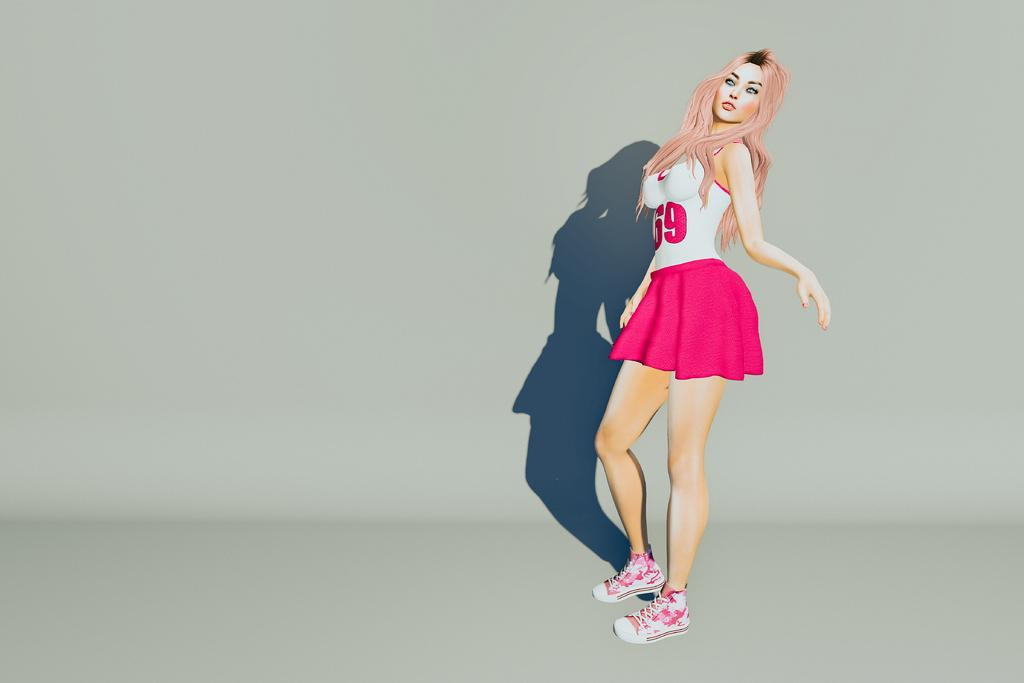What type of image is being described? The image is animated. Who is present in the image? There is a woman in the image. What is the woman doing in the image? The woman is standing in the image. Which direction is the woman facing? The woman is facing towards the left side. What color is the background of the image? The background of the image is white. What time of day is it in the lunchroom, as depicted in the image? There is no lunchroom present in the image, and therefore no indication of the time of day. 